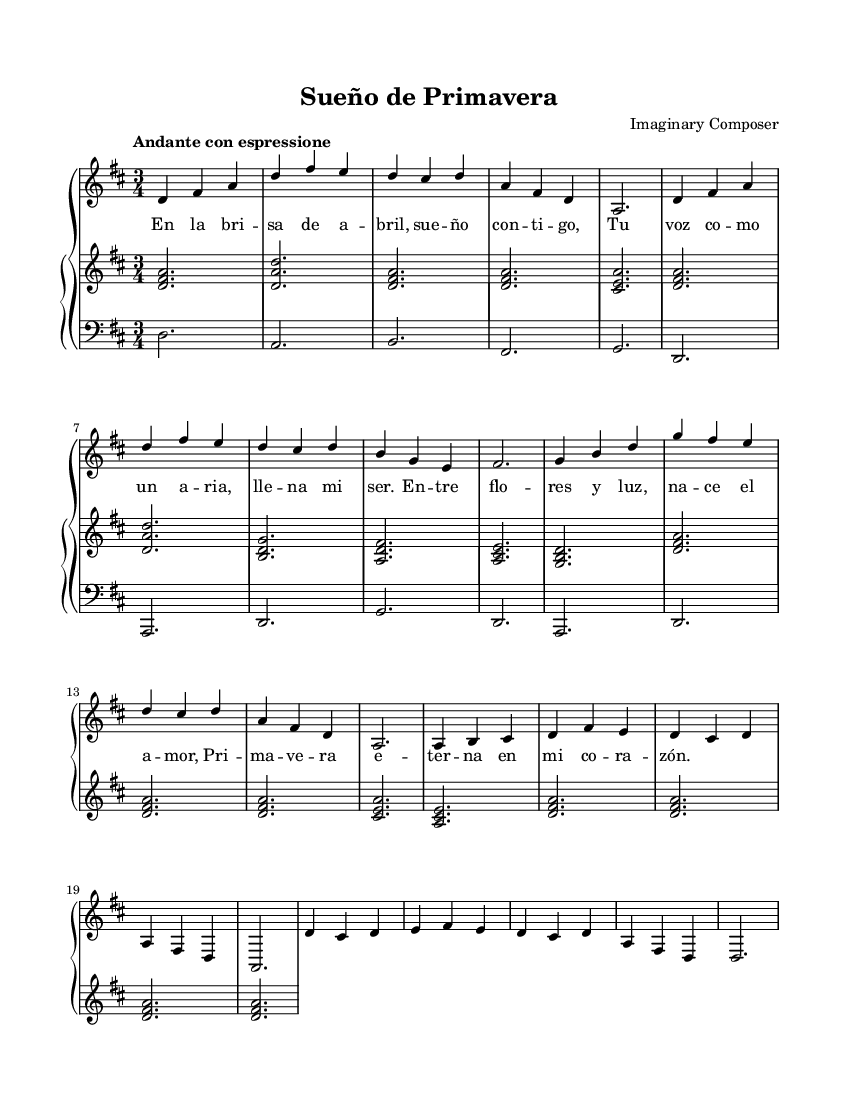What is the key signature of this music? The key signature is D major, which has two sharps (F# and C#). This can be identified by looking at the key signature notation at the beginning of the sheet music.
Answer: D major What is the time signature of this music? The time signature is 3/4. This is indicated by the notation at the beginning of the sheet music, showing 3 beats per measure and the quarter note receiving one beat.
Answer: 3/4 What is the tempo marking for this piece? The tempo marking is "Andante con espressione." This can be found in the tempo indication at the beginning of the sheet music, guiding the performer on the speed and expressive nature of the piece.
Answer: Andante con espressione How many measures are in the melody section? There are 8 measures in the melody section. This is counted by identifying each bar line in the sheet music, which indicates the end of each measure.
Answer: 8 What is the overall dynamic marking indicated in the score? The overall dynamic marking is not explicitly provided within the provided data, but typically, one would look for indications such as "p" for piano or "f" for forte. However, it's not present in the current sheet music.
Answer: None What type of vocal technique is suggested by the use of "con espressione" in the tempo? The phrase "con espressione" suggests a technique of expressive singing. It indicates that the performer should convey emotion and feeling in the performance, emphasizing interpretative delivery.
Answer: Expressive singing How does the text reflect the emotional content typical of Latin American art songs? The text reflects themes of love and nature, which are common in Latin American art songs. The lyrics describe vivid imagery and emotional experiences, appealing to universal sentiments.
Answer: Love and nature themes 